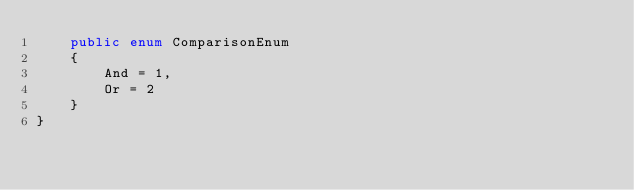<code> <loc_0><loc_0><loc_500><loc_500><_C#_>    public enum ComparisonEnum
    {
        And = 1,
        Or = 2
    }
}
</code> 